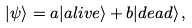Convert formula to latex. <formula><loc_0><loc_0><loc_500><loc_500>| \psi \rangle = a | a l i v e \rangle + b | d e a d \rangle \, ,</formula> 